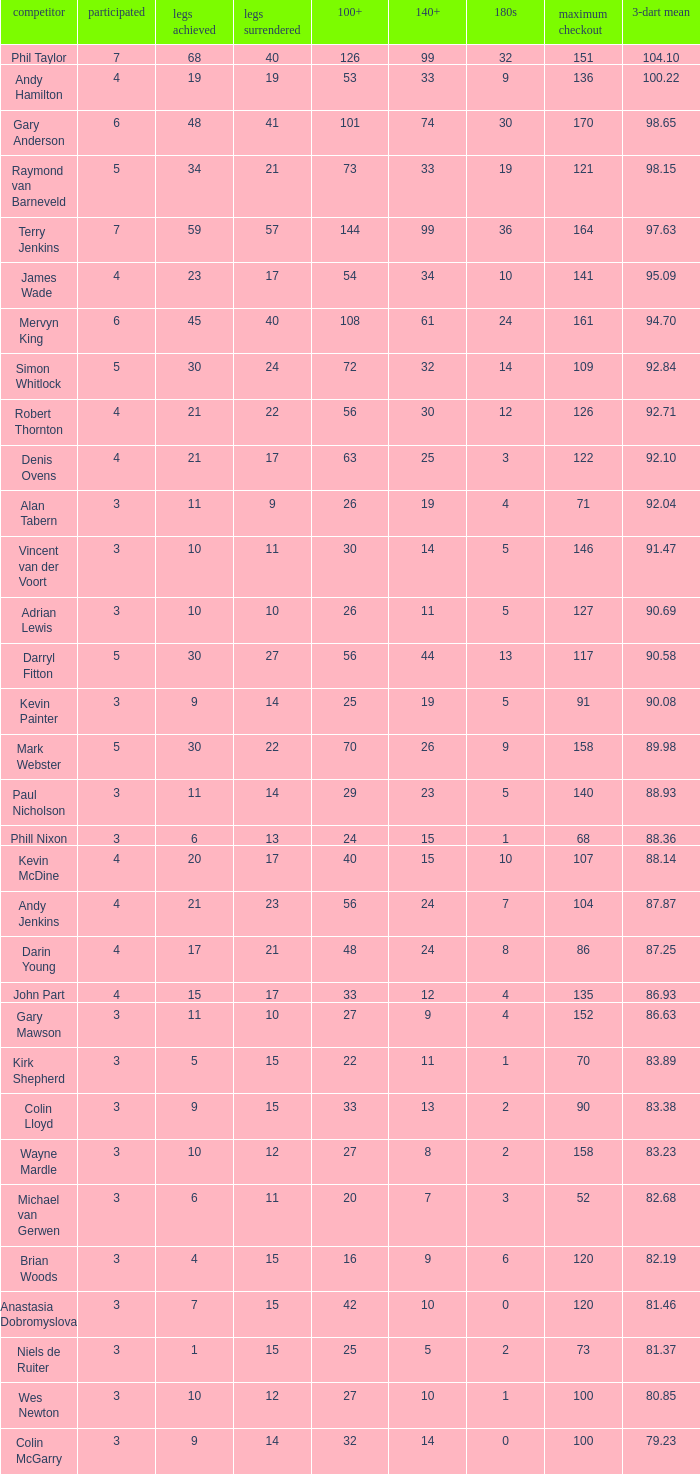What is the number of high checkout when legs Lost is 17, 140+ is 15, and played is larger than 4? None. 